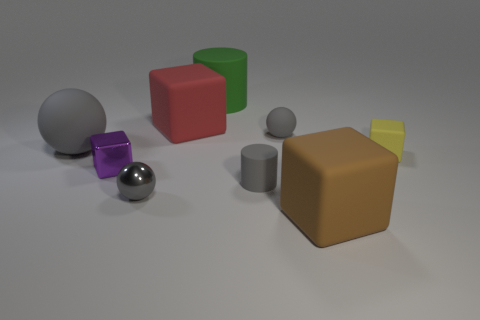The other tiny object that is the same shape as the green object is what color?
Keep it short and to the point. Gray. What number of things are either tiny gray spheres behind the yellow block or gray objects that are to the right of the large gray sphere?
Your response must be concise. 3. The big brown matte thing has what shape?
Provide a succinct answer. Cube. What shape is the shiny thing that is the same color as the large ball?
Your answer should be very brief. Sphere. How many large cylinders have the same material as the large brown block?
Keep it short and to the point. 1. The tiny metal cube is what color?
Your response must be concise. Purple. What is the color of the matte sphere that is the same size as the metallic block?
Your response must be concise. Gray. Is there a big cylinder of the same color as the big rubber ball?
Make the answer very short. No. There is a rubber thing to the right of the big brown matte cube; is its shape the same as the small matte object in front of the yellow block?
Make the answer very short. No. There is a cylinder that is the same color as the shiny ball; what size is it?
Your answer should be compact. Small. 